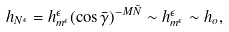<formula> <loc_0><loc_0><loc_500><loc_500>h _ { N ^ { \epsilon } } = h _ { m ^ { \epsilon } } ^ { \epsilon } ( \cos \bar { \gamma } ) ^ { - M \bar { N } } \sim h _ { m ^ { \epsilon } } ^ { \epsilon } \sim h _ { o } ,</formula> 